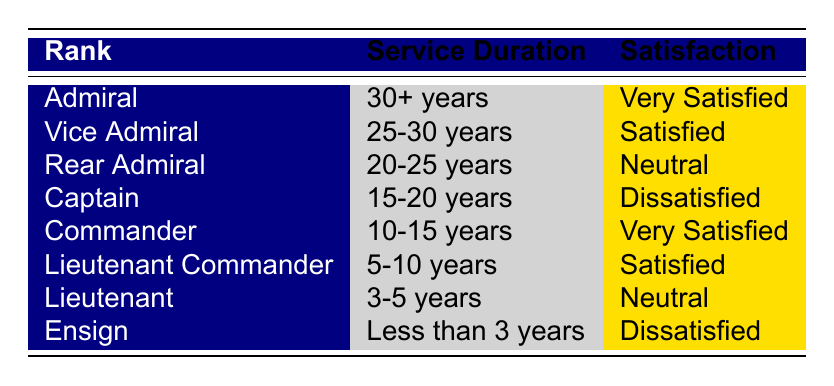What is the satisfaction level of Admirals? The table shows that the satisfaction level for the rank of Admiral is "Very Satisfied."
Answer: Very Satisfied How many ranks have a satisfaction level of "Satisfied"? The ranks with the "Satisfied" level are Vice Admiral and Lieutenant Commander, totaling 2 ranks.
Answer: 2 Which rank has a satisfaction level of "Neutral"? The ranks that have the satisfaction level "Neutral" are Rear Admiral and Lieutenant. Both ranks are listed in the table.
Answer: Rear Admiral and Lieutenant Is the satisfaction level of Ensign "Dissatisfied"? Yes, according to the table, the satisfaction level for the rank of Ensign is "Dissatisfied."
Answer: Yes What is the average satisfaction level for ranks with service duration of 15 years or longer? The ranks with 15+ years of service are Admiral (Very Satisfied), Vice Admiral (Satisfied), Rear Admiral (Neutral), and Captain (Dissatisfied). This results in "Very Satisfied," "Satisfied," "Neutral," and "Dissatisfied." Considering a simple scoring system (Very Satisfied=4, Satisfied=3, Neutral=2, Dissatisfied=1), the average satisfaction score is (4 + 3 + 2 + 1) / 4 = 2.5, which falls between "Neutral" and "Satisfied." Thus, the average satisfaction level can be considered as "Neutral."
Answer: Neutral Which rank has the lowest satisfaction level? The rank with the lowest satisfaction is the Captain, with a satisfaction level of "Dissatisfied," and also Ensign who shares "Dissatisfied."
Answer: Captain and Ensign How does the satisfaction level differ between ranks of over 20 years of service compared to those under 15 years? For ranks with over 20 years: Admiral (Very Satisfied), Vice Admiral (Satisfied), Rear Admiral (Neutral). For ranks under 15 years: Commander (Very Satisfied), Lieutenant Commander (Satisfied), Lieutenant (Neutral), Ensign (Dissatisfied). Overall, older ranks show a range from "Very Satisfied" to "Neutral," while younger ranks also include "Dissatisfied." Therefore, ranks over 20 years tend to be more satisfied than those under 15 years.
Answer: Older ranks are more satisfied How many ranks are categorized as "Dissatisfied"? There are two ranks categorized as "Dissatisfied": Captain and Ensign, as seen in the table.
Answer: 2 